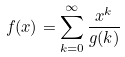Convert formula to latex. <formula><loc_0><loc_0><loc_500><loc_500>f ( x ) = \sum _ { k = 0 } ^ { \infty } \frac { x ^ { k } } { g ( k ) }</formula> 